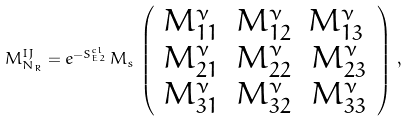Convert formula to latex. <formula><loc_0><loc_0><loc_500><loc_500>M ^ { I J } _ { N _ { R } } = e ^ { - S ^ { c l } _ { E 2 } } \, M _ { s } \, \left ( \begin{array} { c c c } M ^ { \nu } _ { 1 1 } & M ^ { \nu } _ { 1 2 } & M ^ { \nu } _ { 1 3 } \, \\ M ^ { \nu } _ { 2 1 } & M ^ { \nu } _ { 2 2 } & M ^ { \nu } _ { 2 3 } \\ M ^ { \nu } _ { 3 1 } & M ^ { \nu } _ { 3 2 } & M ^ { \nu } _ { 3 3 } \\ \end{array} \right ) \, ,</formula> 